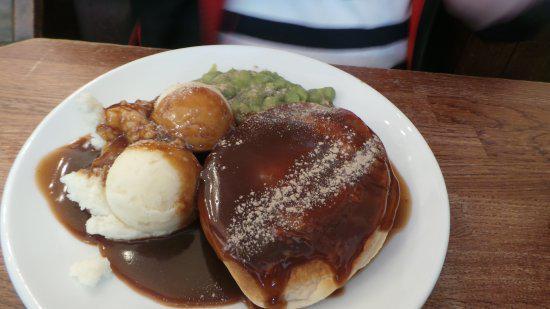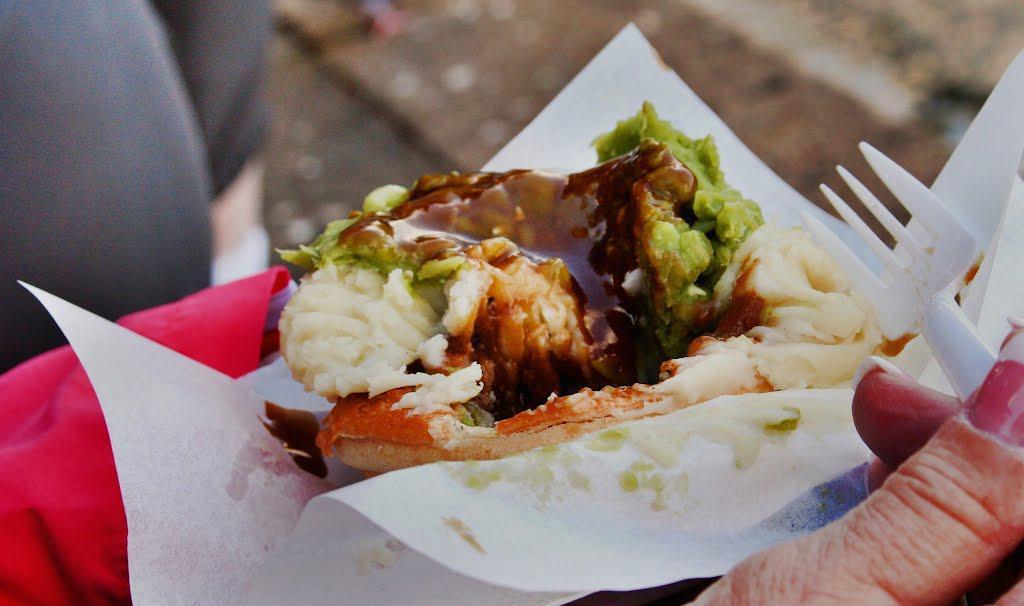The first image is the image on the left, the second image is the image on the right. Evaluate the accuracy of this statement regarding the images: "In one of the images, a spoon is stuck into the top of the food.". Is it true? Answer yes or no. No. 